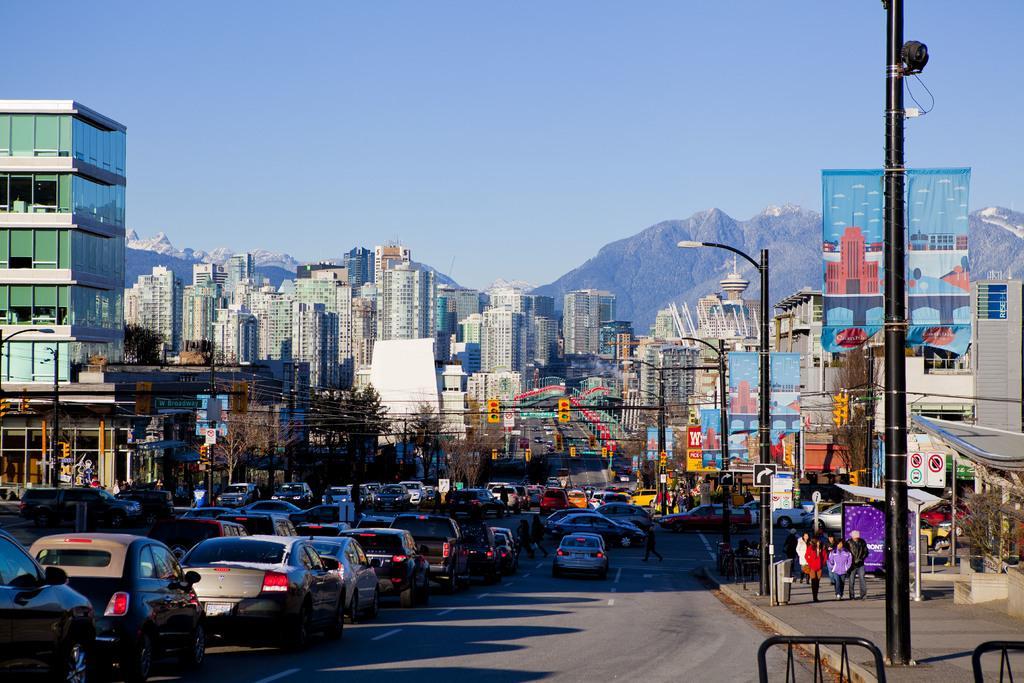Please provide a concise description of this image. In this picture there is a whole view of the city with many buildings. On bottom side of the image we can see the road with many cars in the traffic jam and some black color poles. In the background there are some mountain. 